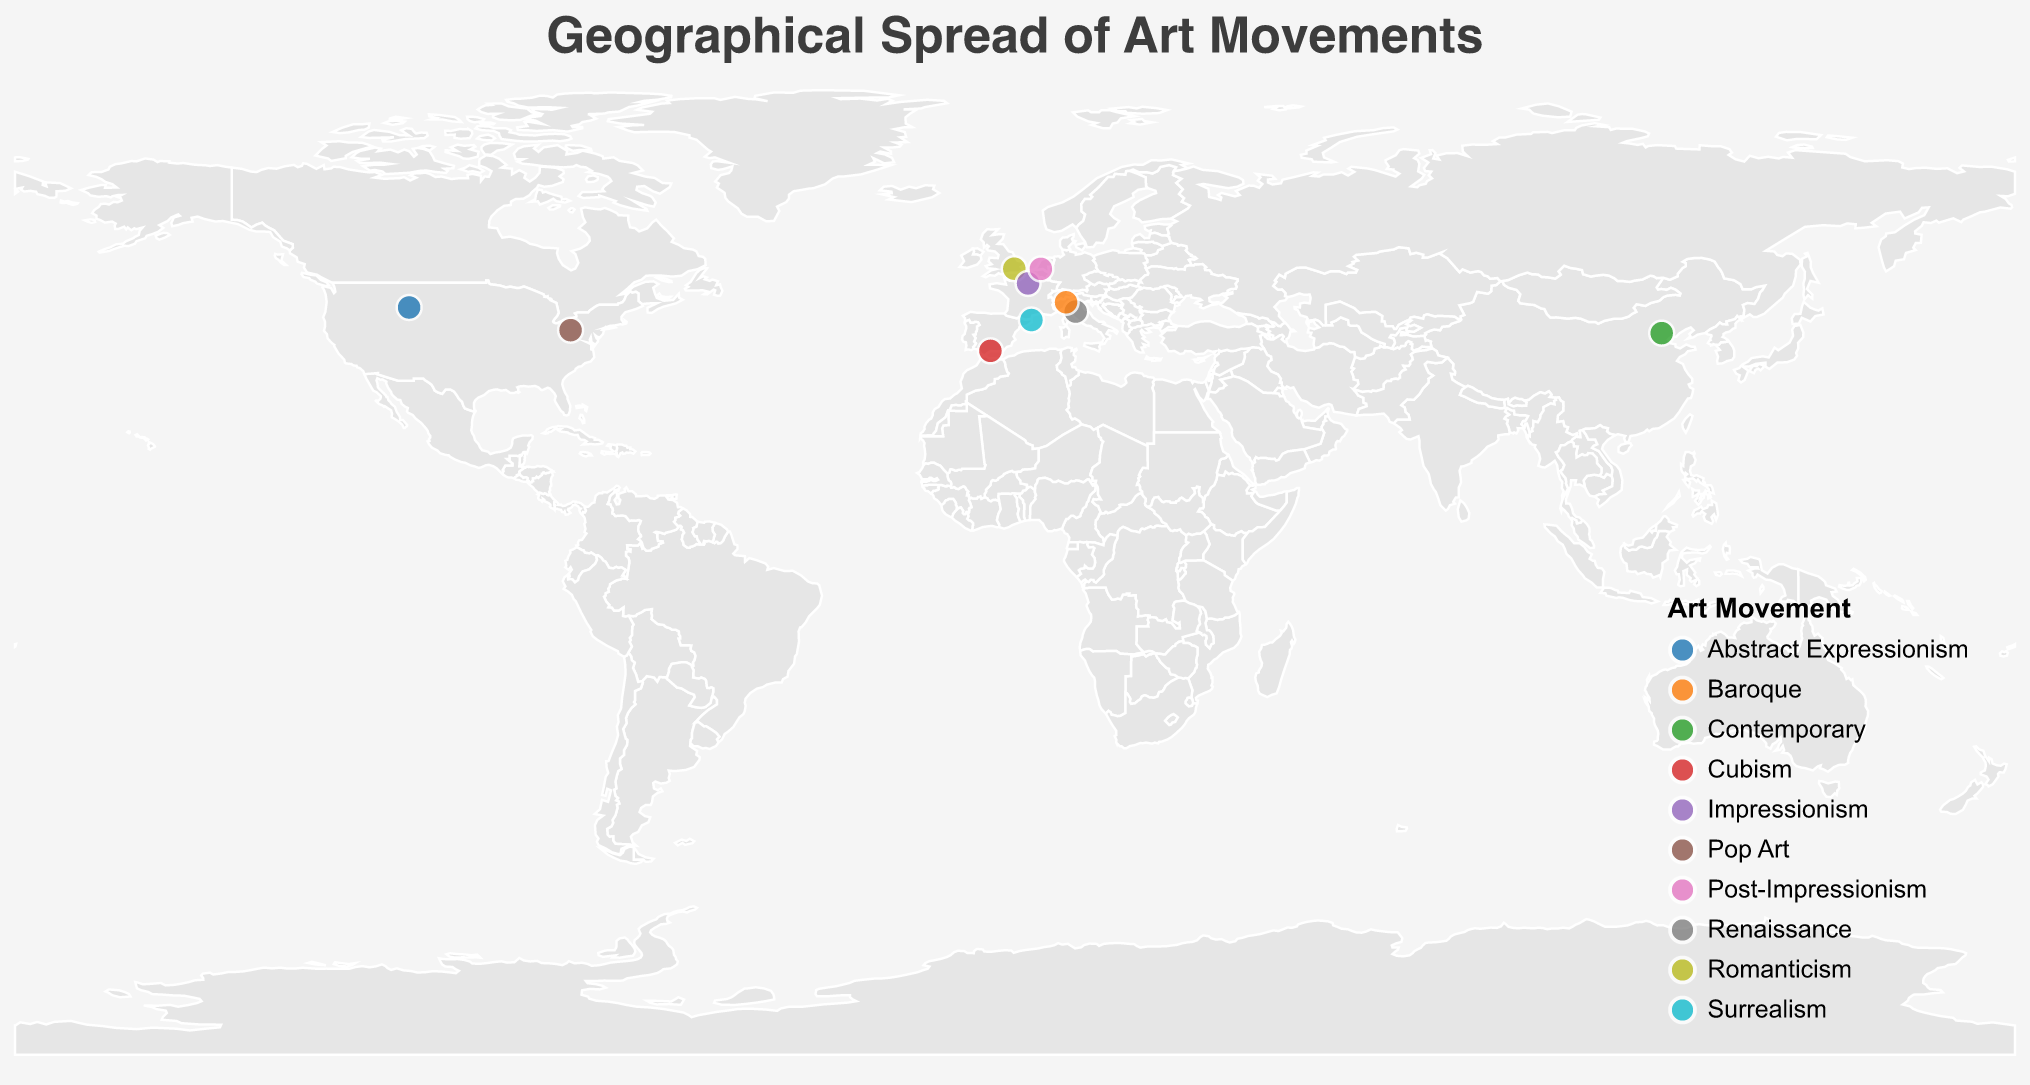what is the title of the figure? The title of the figure is typically found at the top of the plot in large text and indicates the main subject of the visualization.
Answer: Geographical Spread of Art Movements What art movement does the artist Leonardo da Vinci belong to? To find out which art movement Leonardo da Vinci belongs to, look for his name in the tooltip when you hover over the plot point situated in Vinci, Italy.
Answer: Renaissance Which art movement appears earliest chronologically among the listed artists? By examining the birth years of the artists provided in the tooltip and comparing them, the earliest movement can be identified. Leonardo da Vinci, born in 1452, is the earliest.
Answer: Renaissance Which two artists were born in Spain and what art movements do they represent? Find the points located in Spain (Málaga and Figueres) on the map. The tooltip reveals that Pablo Picasso (Cubism) and Salvador Dalí (Surrealism) were born in Spain.
Answer: Pablo Picasso (Cubism) and Salvador Dalí (Surrealism) How many art movements are represented on this map? Each unique color on the map represents a different art movement. By counting the different colors in the legend, you can determine the number of movements.
Answer: 10 Which art movement is represented by the artist born closest to the year 1900? Checking the birth years for artists closest to 1900, Salvador Dalí born in 1904 represents the Surrealism movement.
Answer: Surrealism Which geographical area has the highest concentration of artists' birthplaces? By observing the density of the circles on the map, we can infer that Europe, particularly Western Europe, has the highest concentration of birthplaces for these notable artists.
Answer: Western Europe Between which years do the art movements represented by these artists span? To find the time span, look at the earliest and latest birth years on the map. The earliest is 1452 (Leonardo da Vinci), and the latest is 1957 (Ai Weiwei).
Answer: 1452 to 1957 Which artist and their corresponding movement are located in China? Using the tooltip for the point located in Beijing, China, it identifies the artist Ai Weiwei and his movement, Contemporary.
Answer: Ai Weiwei, Contemporary How many artists in the dataset were born in the 20th century? Check the birth years and count how many fall between 1901 and 2000. Salvador Dalí (1904), Jackson Pollock (1912), and Andy Warhol (1928) fit this criterion.
Answer: 3 